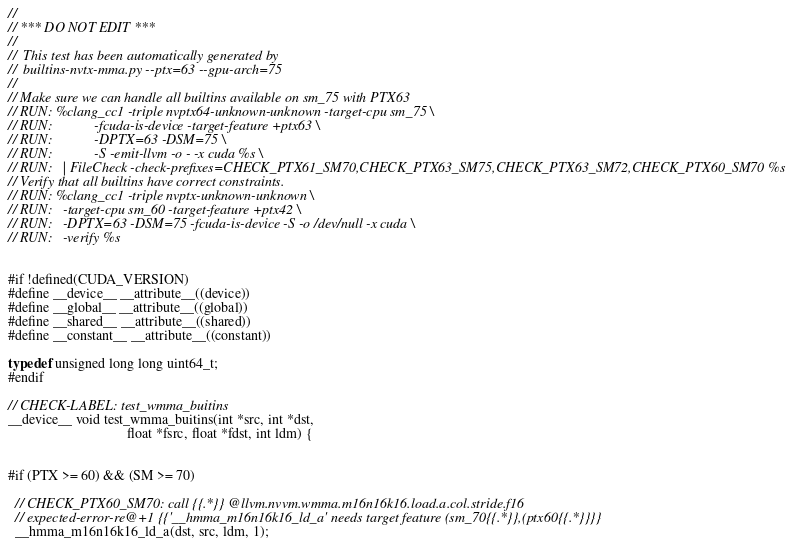Convert code to text. <code><loc_0><loc_0><loc_500><loc_500><_Cuda_>
//
// *** DO NOT EDIT ***
//
//  This test has been automatically generated by
//  builtins-nvtx-mma.py --ptx=63 --gpu-arch=75
//
// Make sure we can handle all builtins available on sm_75 with PTX63
// RUN: %clang_cc1 -triple nvptx64-unknown-unknown -target-cpu sm_75 \
// RUN:            -fcuda-is-device -target-feature +ptx63 \
// RUN:            -DPTX=63 -DSM=75 \
// RUN:            -S -emit-llvm -o - -x cuda %s \
// RUN:   | FileCheck -check-prefixes=CHECK_PTX61_SM70,CHECK_PTX63_SM75,CHECK_PTX63_SM72,CHECK_PTX60_SM70 %s
// Verify that all builtins have correct constraints.
// RUN: %clang_cc1 -triple nvptx-unknown-unknown \
// RUN:   -target-cpu sm_60 -target-feature +ptx42 \
// RUN:   -DPTX=63 -DSM=75 -fcuda-is-device -S -o /dev/null -x cuda \
// RUN:   -verify %s


#if !defined(CUDA_VERSION)
#define __device__ __attribute__((device))
#define __global__ __attribute__((global))
#define __shared__ __attribute__((shared))
#define __constant__ __attribute__((constant))

typedef unsigned long long uint64_t;
#endif

// CHECK-LABEL: test_wmma_buitins
__device__ void test_wmma_buitins(int *src, int *dst,
                                  float *fsrc, float *fdst, int ldm) {


#if (PTX >= 60) && (SM >= 70)

  // CHECK_PTX60_SM70: call {{.*}} @llvm.nvvm.wmma.m16n16k16.load.a.col.stride.f16
  // expected-error-re@+1 {{'__hmma_m16n16k16_ld_a' needs target feature (sm_70{{.*}},(ptx60{{.*}}}}
  __hmma_m16n16k16_ld_a(dst, src, ldm, 1);</code> 